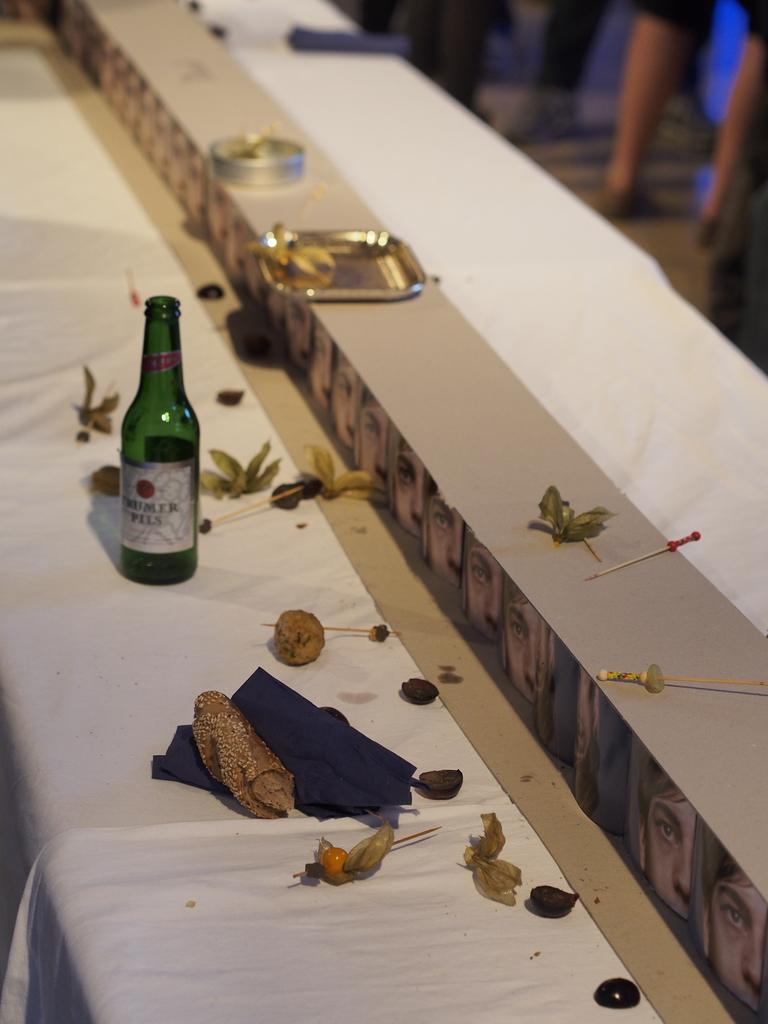What type of container is visible in the image? There is a glass bottle in the image. What else can be seen in the image besides the glass bottle? There are food items, a plate, and a toothpick in the image. What might be used to pick up small pieces of food in the image? The toothpick in the image can be used to pick up small pieces of food. What other objects are present on the table in the image? There are other objects on the table in the image, but their specific details are not mentioned in the provided facts. What type of building is visible in the image? There is no building present in the image. What type of meat is being served on the plate in the image? There is no meat present in the image; only food items are mentioned. 